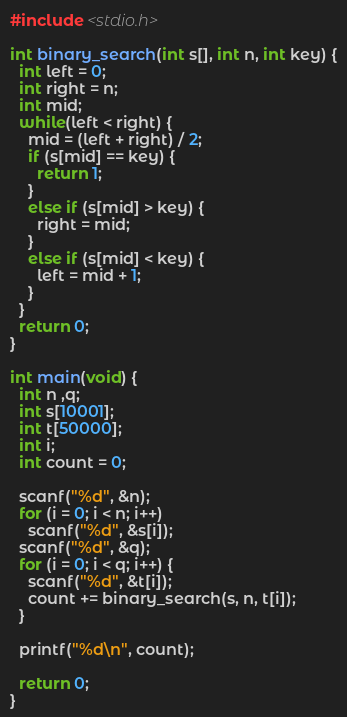Convert code to text. <code><loc_0><loc_0><loc_500><loc_500><_C_>#include <stdio.h>

int binary_search(int s[], int n, int key) {
  int left = 0;
  int right = n;
  int mid;
  while(left < right) {
    mid = (left + right) / 2;
    if (s[mid] == key) {
      return 1;
    }
    else if (s[mid] > key) {
      right = mid;
    }
    else if (s[mid] < key) {
      left = mid + 1;
    }
  }
  return 0;
}
  
int main(void) {
  int n ,q;
  int s[10001];
  int t[50000];
  int i;
  int count = 0;
    
  scanf("%d", &n);
  for (i = 0; i < n; i++)
    scanf("%d", &s[i]);
  scanf("%d", &q);
  for (i = 0; i < q; i++) {
    scanf("%d", &t[i]);
    count += binary_search(s, n, t[i]);
  }
  
  printf("%d\n", count);
    
  return 0;
}

</code> 